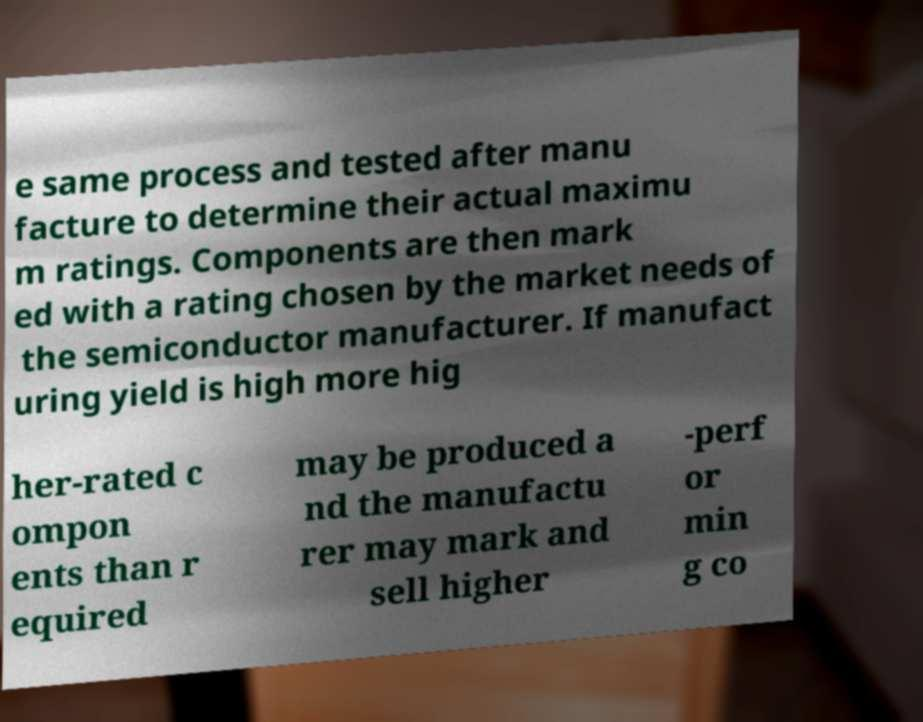What messages or text are displayed in this image? I need them in a readable, typed format. e same process and tested after manu facture to determine their actual maximu m ratings. Components are then mark ed with a rating chosen by the market needs of the semiconductor manufacturer. If manufact uring yield is high more hig her-rated c ompon ents than r equired may be produced a nd the manufactu rer may mark and sell higher -perf or min g co 